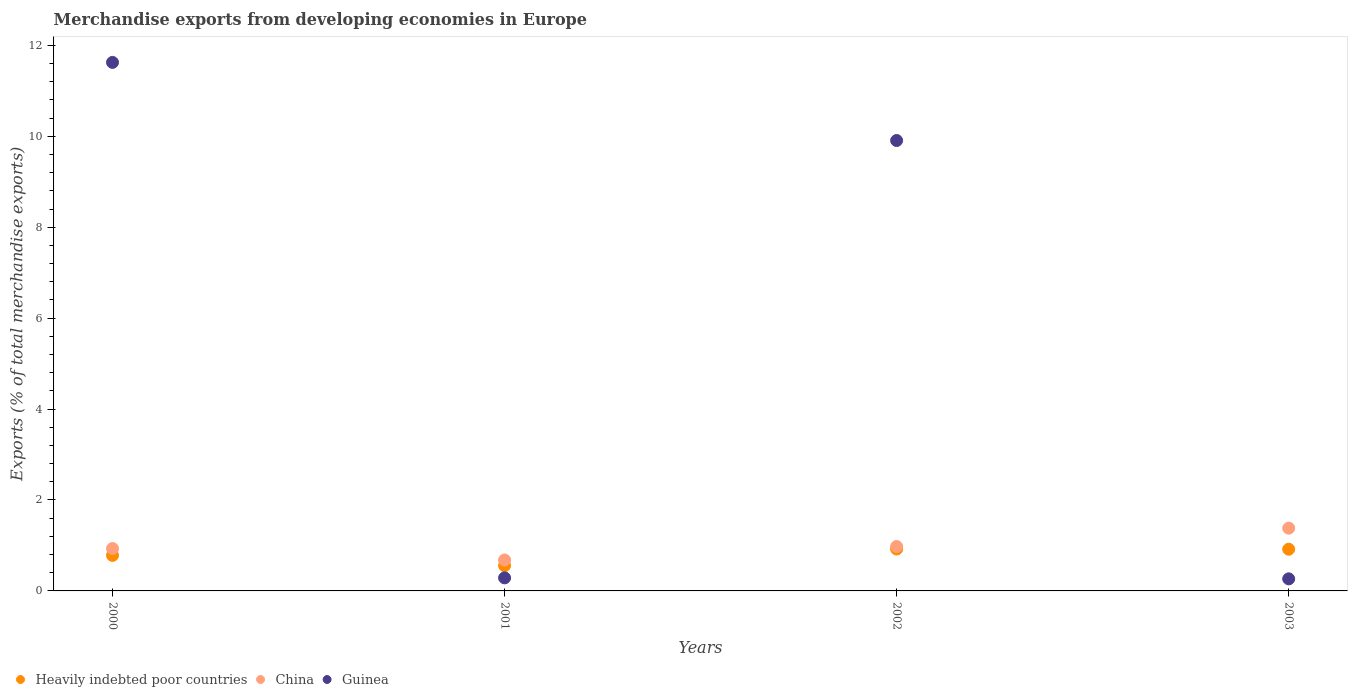How many different coloured dotlines are there?
Offer a very short reply. 3. What is the percentage of total merchandise exports in China in 2000?
Ensure brevity in your answer.  0.93. Across all years, what is the maximum percentage of total merchandise exports in China?
Ensure brevity in your answer.  1.38. Across all years, what is the minimum percentage of total merchandise exports in Heavily indebted poor countries?
Your answer should be compact. 0.56. In which year was the percentage of total merchandise exports in Heavily indebted poor countries maximum?
Offer a very short reply. 2002. What is the total percentage of total merchandise exports in Heavily indebted poor countries in the graph?
Offer a terse response. 3.18. What is the difference between the percentage of total merchandise exports in Guinea in 2001 and that in 2002?
Your answer should be compact. -9.62. What is the difference between the percentage of total merchandise exports in China in 2002 and the percentage of total merchandise exports in Heavily indebted poor countries in 2001?
Provide a short and direct response. 0.42. What is the average percentage of total merchandise exports in China per year?
Offer a terse response. 0.99. In the year 2002, what is the difference between the percentage of total merchandise exports in Guinea and percentage of total merchandise exports in Heavily indebted poor countries?
Ensure brevity in your answer.  8.99. What is the ratio of the percentage of total merchandise exports in Heavily indebted poor countries in 2000 to that in 2002?
Your response must be concise. 0.85. Is the percentage of total merchandise exports in Heavily indebted poor countries in 2000 less than that in 2001?
Make the answer very short. No. Is the difference between the percentage of total merchandise exports in Guinea in 2001 and 2003 greater than the difference between the percentage of total merchandise exports in Heavily indebted poor countries in 2001 and 2003?
Your answer should be compact. Yes. What is the difference between the highest and the second highest percentage of total merchandise exports in Guinea?
Make the answer very short. 1.72. What is the difference between the highest and the lowest percentage of total merchandise exports in Guinea?
Your answer should be compact. 11.36. In how many years, is the percentage of total merchandise exports in Heavily indebted poor countries greater than the average percentage of total merchandise exports in Heavily indebted poor countries taken over all years?
Give a very brief answer. 2. Is the percentage of total merchandise exports in Guinea strictly greater than the percentage of total merchandise exports in Heavily indebted poor countries over the years?
Offer a very short reply. No. How many years are there in the graph?
Keep it short and to the point. 4. Does the graph contain any zero values?
Your answer should be very brief. No. Does the graph contain grids?
Your response must be concise. No. Where does the legend appear in the graph?
Offer a very short reply. Bottom left. What is the title of the graph?
Provide a short and direct response. Merchandise exports from developing economies in Europe. What is the label or title of the Y-axis?
Your response must be concise. Exports (% of total merchandise exports). What is the Exports (% of total merchandise exports) in Heavily indebted poor countries in 2000?
Offer a terse response. 0.78. What is the Exports (% of total merchandise exports) in China in 2000?
Provide a succinct answer. 0.93. What is the Exports (% of total merchandise exports) of Guinea in 2000?
Make the answer very short. 11.63. What is the Exports (% of total merchandise exports) of Heavily indebted poor countries in 2001?
Offer a terse response. 0.56. What is the Exports (% of total merchandise exports) of China in 2001?
Your answer should be compact. 0.68. What is the Exports (% of total merchandise exports) in Guinea in 2001?
Give a very brief answer. 0.29. What is the Exports (% of total merchandise exports) of Heavily indebted poor countries in 2002?
Offer a very short reply. 0.92. What is the Exports (% of total merchandise exports) in China in 2002?
Your answer should be very brief. 0.98. What is the Exports (% of total merchandise exports) in Guinea in 2002?
Give a very brief answer. 9.91. What is the Exports (% of total merchandise exports) of Heavily indebted poor countries in 2003?
Provide a short and direct response. 0.92. What is the Exports (% of total merchandise exports) in China in 2003?
Your answer should be compact. 1.38. What is the Exports (% of total merchandise exports) in Guinea in 2003?
Ensure brevity in your answer.  0.27. Across all years, what is the maximum Exports (% of total merchandise exports) of Heavily indebted poor countries?
Offer a very short reply. 0.92. Across all years, what is the maximum Exports (% of total merchandise exports) in China?
Keep it short and to the point. 1.38. Across all years, what is the maximum Exports (% of total merchandise exports) in Guinea?
Offer a very short reply. 11.63. Across all years, what is the minimum Exports (% of total merchandise exports) of Heavily indebted poor countries?
Provide a succinct answer. 0.56. Across all years, what is the minimum Exports (% of total merchandise exports) in China?
Provide a short and direct response. 0.68. Across all years, what is the minimum Exports (% of total merchandise exports) in Guinea?
Give a very brief answer. 0.27. What is the total Exports (% of total merchandise exports) of Heavily indebted poor countries in the graph?
Give a very brief answer. 3.18. What is the total Exports (% of total merchandise exports) in China in the graph?
Provide a short and direct response. 3.97. What is the total Exports (% of total merchandise exports) of Guinea in the graph?
Provide a short and direct response. 22.09. What is the difference between the Exports (% of total merchandise exports) in Heavily indebted poor countries in 2000 and that in 2001?
Give a very brief answer. 0.23. What is the difference between the Exports (% of total merchandise exports) of China in 2000 and that in 2001?
Offer a very short reply. 0.25. What is the difference between the Exports (% of total merchandise exports) of Guinea in 2000 and that in 2001?
Offer a terse response. 11.34. What is the difference between the Exports (% of total merchandise exports) of Heavily indebted poor countries in 2000 and that in 2002?
Make the answer very short. -0.14. What is the difference between the Exports (% of total merchandise exports) in China in 2000 and that in 2002?
Make the answer very short. -0.04. What is the difference between the Exports (% of total merchandise exports) in Guinea in 2000 and that in 2002?
Give a very brief answer. 1.72. What is the difference between the Exports (% of total merchandise exports) in Heavily indebted poor countries in 2000 and that in 2003?
Ensure brevity in your answer.  -0.14. What is the difference between the Exports (% of total merchandise exports) in China in 2000 and that in 2003?
Your response must be concise. -0.45. What is the difference between the Exports (% of total merchandise exports) of Guinea in 2000 and that in 2003?
Make the answer very short. 11.36. What is the difference between the Exports (% of total merchandise exports) in Heavily indebted poor countries in 2001 and that in 2002?
Give a very brief answer. -0.37. What is the difference between the Exports (% of total merchandise exports) in China in 2001 and that in 2002?
Provide a succinct answer. -0.3. What is the difference between the Exports (% of total merchandise exports) of Guinea in 2001 and that in 2002?
Your answer should be compact. -9.62. What is the difference between the Exports (% of total merchandise exports) in Heavily indebted poor countries in 2001 and that in 2003?
Your answer should be very brief. -0.36. What is the difference between the Exports (% of total merchandise exports) in Guinea in 2001 and that in 2003?
Provide a short and direct response. 0.02. What is the difference between the Exports (% of total merchandise exports) of Heavily indebted poor countries in 2002 and that in 2003?
Make the answer very short. 0. What is the difference between the Exports (% of total merchandise exports) of China in 2002 and that in 2003?
Your response must be concise. -0.4. What is the difference between the Exports (% of total merchandise exports) in Guinea in 2002 and that in 2003?
Your response must be concise. 9.64. What is the difference between the Exports (% of total merchandise exports) in Heavily indebted poor countries in 2000 and the Exports (% of total merchandise exports) in China in 2001?
Offer a terse response. 0.1. What is the difference between the Exports (% of total merchandise exports) of Heavily indebted poor countries in 2000 and the Exports (% of total merchandise exports) of Guinea in 2001?
Provide a succinct answer. 0.49. What is the difference between the Exports (% of total merchandise exports) of China in 2000 and the Exports (% of total merchandise exports) of Guinea in 2001?
Your answer should be compact. 0.65. What is the difference between the Exports (% of total merchandise exports) in Heavily indebted poor countries in 2000 and the Exports (% of total merchandise exports) in China in 2002?
Provide a succinct answer. -0.2. What is the difference between the Exports (% of total merchandise exports) of Heavily indebted poor countries in 2000 and the Exports (% of total merchandise exports) of Guinea in 2002?
Your response must be concise. -9.13. What is the difference between the Exports (% of total merchandise exports) of China in 2000 and the Exports (% of total merchandise exports) of Guinea in 2002?
Your response must be concise. -8.97. What is the difference between the Exports (% of total merchandise exports) of Heavily indebted poor countries in 2000 and the Exports (% of total merchandise exports) of China in 2003?
Offer a very short reply. -0.6. What is the difference between the Exports (% of total merchandise exports) in Heavily indebted poor countries in 2000 and the Exports (% of total merchandise exports) in Guinea in 2003?
Your answer should be very brief. 0.52. What is the difference between the Exports (% of total merchandise exports) in China in 2000 and the Exports (% of total merchandise exports) in Guinea in 2003?
Give a very brief answer. 0.67. What is the difference between the Exports (% of total merchandise exports) in Heavily indebted poor countries in 2001 and the Exports (% of total merchandise exports) in China in 2002?
Offer a very short reply. -0.42. What is the difference between the Exports (% of total merchandise exports) of Heavily indebted poor countries in 2001 and the Exports (% of total merchandise exports) of Guinea in 2002?
Your response must be concise. -9.35. What is the difference between the Exports (% of total merchandise exports) in China in 2001 and the Exports (% of total merchandise exports) in Guinea in 2002?
Ensure brevity in your answer.  -9.23. What is the difference between the Exports (% of total merchandise exports) in Heavily indebted poor countries in 2001 and the Exports (% of total merchandise exports) in China in 2003?
Keep it short and to the point. -0.82. What is the difference between the Exports (% of total merchandise exports) of Heavily indebted poor countries in 2001 and the Exports (% of total merchandise exports) of Guinea in 2003?
Give a very brief answer. 0.29. What is the difference between the Exports (% of total merchandise exports) of China in 2001 and the Exports (% of total merchandise exports) of Guinea in 2003?
Offer a terse response. 0.41. What is the difference between the Exports (% of total merchandise exports) in Heavily indebted poor countries in 2002 and the Exports (% of total merchandise exports) in China in 2003?
Your response must be concise. -0.46. What is the difference between the Exports (% of total merchandise exports) in Heavily indebted poor countries in 2002 and the Exports (% of total merchandise exports) in Guinea in 2003?
Provide a succinct answer. 0.66. What is the difference between the Exports (% of total merchandise exports) of China in 2002 and the Exports (% of total merchandise exports) of Guinea in 2003?
Provide a succinct answer. 0.71. What is the average Exports (% of total merchandise exports) in Heavily indebted poor countries per year?
Your response must be concise. 0.79. What is the average Exports (% of total merchandise exports) of Guinea per year?
Offer a terse response. 5.52. In the year 2000, what is the difference between the Exports (% of total merchandise exports) in Heavily indebted poor countries and Exports (% of total merchandise exports) in China?
Give a very brief answer. -0.15. In the year 2000, what is the difference between the Exports (% of total merchandise exports) in Heavily indebted poor countries and Exports (% of total merchandise exports) in Guinea?
Offer a terse response. -10.84. In the year 2000, what is the difference between the Exports (% of total merchandise exports) in China and Exports (% of total merchandise exports) in Guinea?
Ensure brevity in your answer.  -10.69. In the year 2001, what is the difference between the Exports (% of total merchandise exports) of Heavily indebted poor countries and Exports (% of total merchandise exports) of China?
Ensure brevity in your answer.  -0.12. In the year 2001, what is the difference between the Exports (% of total merchandise exports) of Heavily indebted poor countries and Exports (% of total merchandise exports) of Guinea?
Provide a short and direct response. 0.27. In the year 2001, what is the difference between the Exports (% of total merchandise exports) of China and Exports (% of total merchandise exports) of Guinea?
Your response must be concise. 0.39. In the year 2002, what is the difference between the Exports (% of total merchandise exports) in Heavily indebted poor countries and Exports (% of total merchandise exports) in China?
Give a very brief answer. -0.06. In the year 2002, what is the difference between the Exports (% of total merchandise exports) of Heavily indebted poor countries and Exports (% of total merchandise exports) of Guinea?
Make the answer very short. -8.99. In the year 2002, what is the difference between the Exports (% of total merchandise exports) in China and Exports (% of total merchandise exports) in Guinea?
Provide a short and direct response. -8.93. In the year 2003, what is the difference between the Exports (% of total merchandise exports) of Heavily indebted poor countries and Exports (% of total merchandise exports) of China?
Ensure brevity in your answer.  -0.46. In the year 2003, what is the difference between the Exports (% of total merchandise exports) in Heavily indebted poor countries and Exports (% of total merchandise exports) in Guinea?
Provide a succinct answer. 0.65. In the year 2003, what is the difference between the Exports (% of total merchandise exports) of China and Exports (% of total merchandise exports) of Guinea?
Ensure brevity in your answer.  1.11. What is the ratio of the Exports (% of total merchandise exports) in Heavily indebted poor countries in 2000 to that in 2001?
Make the answer very short. 1.4. What is the ratio of the Exports (% of total merchandise exports) in China in 2000 to that in 2001?
Offer a terse response. 1.37. What is the ratio of the Exports (% of total merchandise exports) of Guinea in 2000 to that in 2001?
Keep it short and to the point. 40.49. What is the ratio of the Exports (% of total merchandise exports) of Heavily indebted poor countries in 2000 to that in 2002?
Give a very brief answer. 0.85. What is the ratio of the Exports (% of total merchandise exports) in China in 2000 to that in 2002?
Provide a short and direct response. 0.95. What is the ratio of the Exports (% of total merchandise exports) of Guinea in 2000 to that in 2002?
Your answer should be very brief. 1.17. What is the ratio of the Exports (% of total merchandise exports) in Heavily indebted poor countries in 2000 to that in 2003?
Offer a terse response. 0.85. What is the ratio of the Exports (% of total merchandise exports) of China in 2000 to that in 2003?
Offer a very short reply. 0.68. What is the ratio of the Exports (% of total merchandise exports) in Guinea in 2000 to that in 2003?
Give a very brief answer. 43.77. What is the ratio of the Exports (% of total merchandise exports) in Heavily indebted poor countries in 2001 to that in 2002?
Ensure brevity in your answer.  0.6. What is the ratio of the Exports (% of total merchandise exports) of China in 2001 to that in 2002?
Your answer should be very brief. 0.7. What is the ratio of the Exports (% of total merchandise exports) of Guinea in 2001 to that in 2002?
Make the answer very short. 0.03. What is the ratio of the Exports (% of total merchandise exports) of Heavily indebted poor countries in 2001 to that in 2003?
Your answer should be compact. 0.61. What is the ratio of the Exports (% of total merchandise exports) in China in 2001 to that in 2003?
Ensure brevity in your answer.  0.49. What is the ratio of the Exports (% of total merchandise exports) of Guinea in 2001 to that in 2003?
Give a very brief answer. 1.08. What is the ratio of the Exports (% of total merchandise exports) of China in 2002 to that in 2003?
Your answer should be compact. 0.71. What is the ratio of the Exports (% of total merchandise exports) of Guinea in 2002 to that in 2003?
Offer a terse response. 37.3. What is the difference between the highest and the second highest Exports (% of total merchandise exports) of Heavily indebted poor countries?
Provide a succinct answer. 0. What is the difference between the highest and the second highest Exports (% of total merchandise exports) in China?
Give a very brief answer. 0.4. What is the difference between the highest and the second highest Exports (% of total merchandise exports) in Guinea?
Your response must be concise. 1.72. What is the difference between the highest and the lowest Exports (% of total merchandise exports) of Heavily indebted poor countries?
Your answer should be compact. 0.37. What is the difference between the highest and the lowest Exports (% of total merchandise exports) of China?
Give a very brief answer. 0.7. What is the difference between the highest and the lowest Exports (% of total merchandise exports) in Guinea?
Make the answer very short. 11.36. 